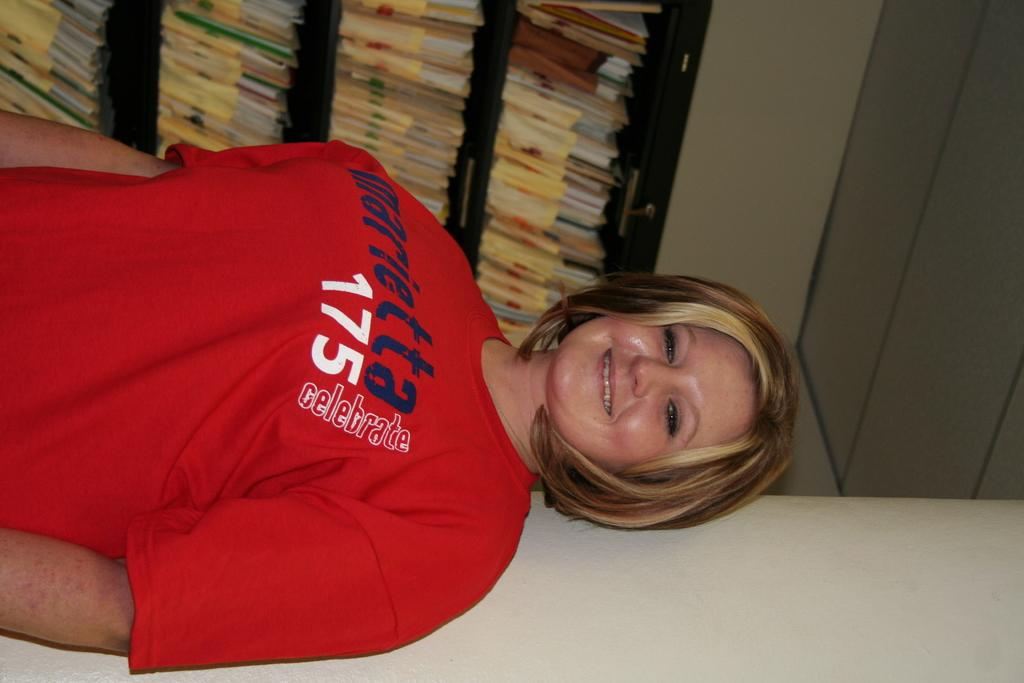Provide a one-sentence caption for the provided image. A woman in a red t shirt with the digit 175. 